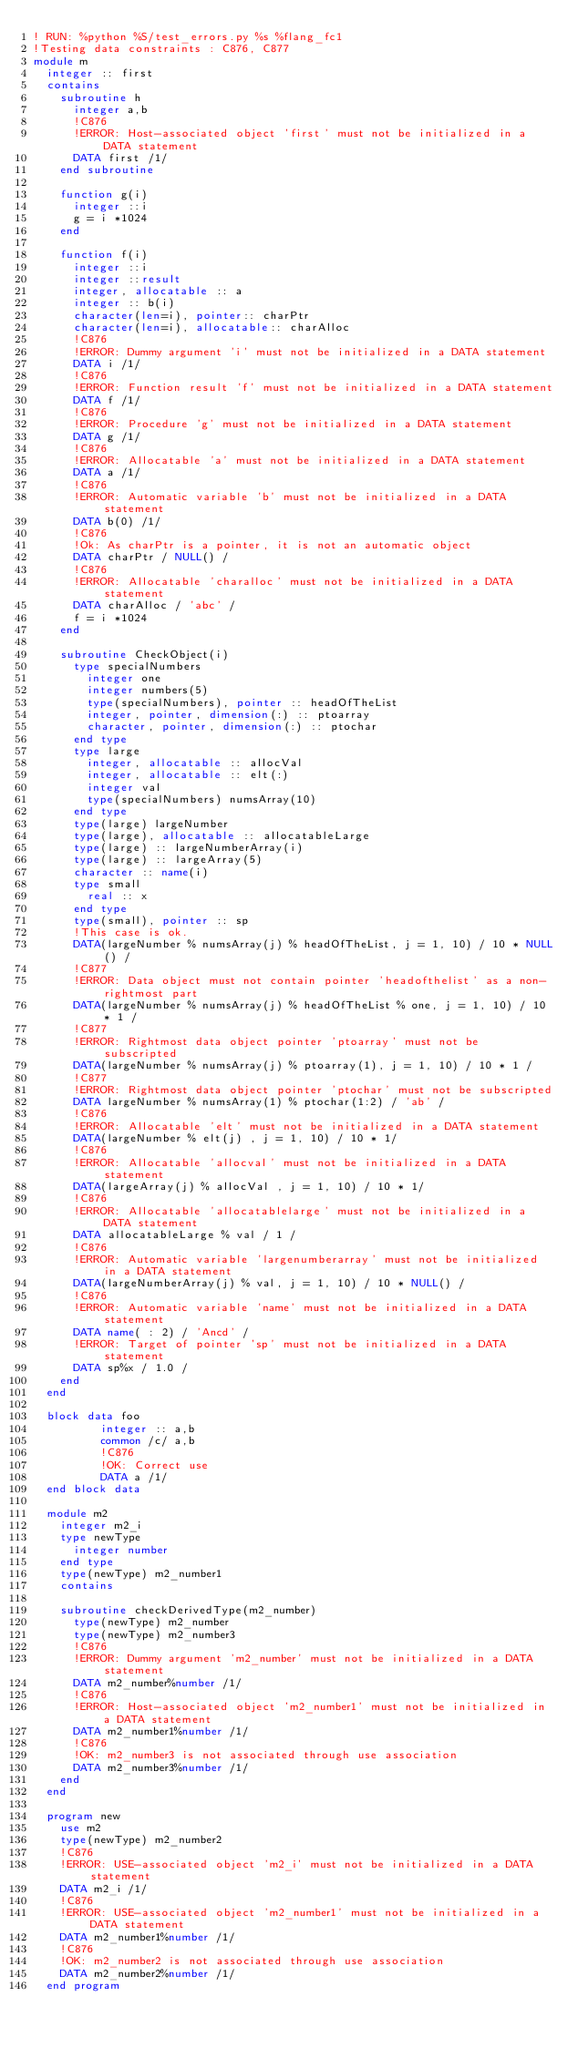<code> <loc_0><loc_0><loc_500><loc_500><_FORTRAN_>! RUN: %python %S/test_errors.py %s %flang_fc1
!Testing data constraints : C876, C877
module m
  integer :: first
  contains
    subroutine h
      integer a,b
      !C876
      !ERROR: Host-associated object 'first' must not be initialized in a DATA statement
      DATA first /1/
    end subroutine

    function g(i)
      integer ::i
      g = i *1024
    end

    function f(i)
      integer ::i
      integer ::result
      integer, allocatable :: a
      integer :: b(i)
      character(len=i), pointer:: charPtr
      character(len=i), allocatable:: charAlloc
      !C876
      !ERROR: Dummy argument 'i' must not be initialized in a DATA statement
      DATA i /1/
      !C876
      !ERROR: Function result 'f' must not be initialized in a DATA statement
      DATA f /1/
      !C876
      !ERROR: Procedure 'g' must not be initialized in a DATA statement
      DATA g /1/
      !C876
      !ERROR: Allocatable 'a' must not be initialized in a DATA statement
      DATA a /1/
      !C876
      !ERROR: Automatic variable 'b' must not be initialized in a DATA statement
      DATA b(0) /1/
      !C876
      !Ok: As charPtr is a pointer, it is not an automatic object
      DATA charPtr / NULL() /
      !C876
      !ERROR: Allocatable 'charalloc' must not be initialized in a DATA statement
      DATA charAlloc / 'abc' /
      f = i *1024
    end

    subroutine CheckObject(i)
      type specialNumbers
        integer one
        integer numbers(5)
        type(specialNumbers), pointer :: headOfTheList
        integer, pointer, dimension(:) :: ptoarray
        character, pointer, dimension(:) :: ptochar
      end type
      type large
        integer, allocatable :: allocVal
        integer, allocatable :: elt(:)
        integer val
        type(specialNumbers) numsArray(10)
      end type
      type(large) largeNumber
      type(large), allocatable :: allocatableLarge
      type(large) :: largeNumberArray(i)
      type(large) :: largeArray(5)
      character :: name(i)
      type small
        real :: x
      end type
      type(small), pointer :: sp
      !This case is ok.
      DATA(largeNumber % numsArray(j) % headOfTheList, j = 1, 10) / 10 * NULL() /
      !C877
      !ERROR: Data object must not contain pointer 'headofthelist' as a non-rightmost part
      DATA(largeNumber % numsArray(j) % headOfTheList % one, j = 1, 10) / 10 * 1 /
      !C877
      !ERROR: Rightmost data object pointer 'ptoarray' must not be subscripted
      DATA(largeNumber % numsArray(j) % ptoarray(1), j = 1, 10) / 10 * 1 /
      !C877
      !ERROR: Rightmost data object pointer 'ptochar' must not be subscripted
      DATA largeNumber % numsArray(1) % ptochar(1:2) / 'ab' /
      !C876
      !ERROR: Allocatable 'elt' must not be initialized in a DATA statement
      DATA(largeNumber % elt(j) , j = 1, 10) / 10 * 1/
      !C876
      !ERROR: Allocatable 'allocval' must not be initialized in a DATA statement
      DATA(largeArray(j) % allocVal , j = 1, 10) / 10 * 1/
      !C876
      !ERROR: Allocatable 'allocatablelarge' must not be initialized in a DATA statement
      DATA allocatableLarge % val / 1 /
      !C876
      !ERROR: Automatic variable 'largenumberarray' must not be initialized in a DATA statement
      DATA(largeNumberArray(j) % val, j = 1, 10) / 10 * NULL() /
      !C876
      !ERROR: Automatic variable 'name' must not be initialized in a DATA statement
      DATA name( : 2) / 'Ancd' /
      !ERROR: Target of pointer 'sp' must not be initialized in a DATA statement
      DATA sp%x / 1.0 /
    end
  end

  block data foo
          integer :: a,b
          common /c/ a,b
          !C876
          !OK: Correct use
          DATA a /1/
  end block data

  module m2
    integer m2_i
    type newType
      integer number
    end type
    type(newType) m2_number1
    contains

    subroutine checkDerivedType(m2_number)
      type(newType) m2_number
      type(newType) m2_number3
      !C876
      !ERROR: Dummy argument 'm2_number' must not be initialized in a DATA statement
      DATA m2_number%number /1/
      !C876
      !ERROR: Host-associated object 'm2_number1' must not be initialized in a DATA statement
      DATA m2_number1%number /1/
      !C876
      !OK: m2_number3 is not associated through use association
      DATA m2_number3%number /1/
    end
  end

  program new
    use m2
    type(newType) m2_number2
    !C876
    !ERROR: USE-associated object 'm2_i' must not be initialized in a DATA statement
    DATA m2_i /1/
    !C876
    !ERROR: USE-associated object 'm2_number1' must not be initialized in a DATA statement
    DATA m2_number1%number /1/
    !C876
    !OK: m2_number2 is not associated through use association
    DATA m2_number2%number /1/
  end program
</code> 